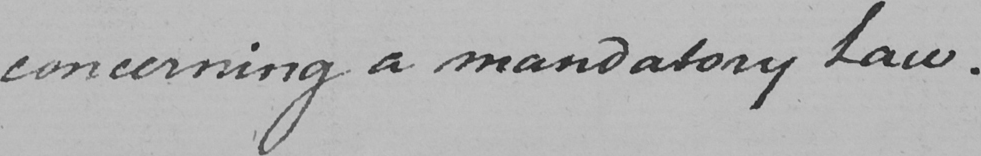Can you read and transcribe this handwriting? concerning a mandatory Law . 